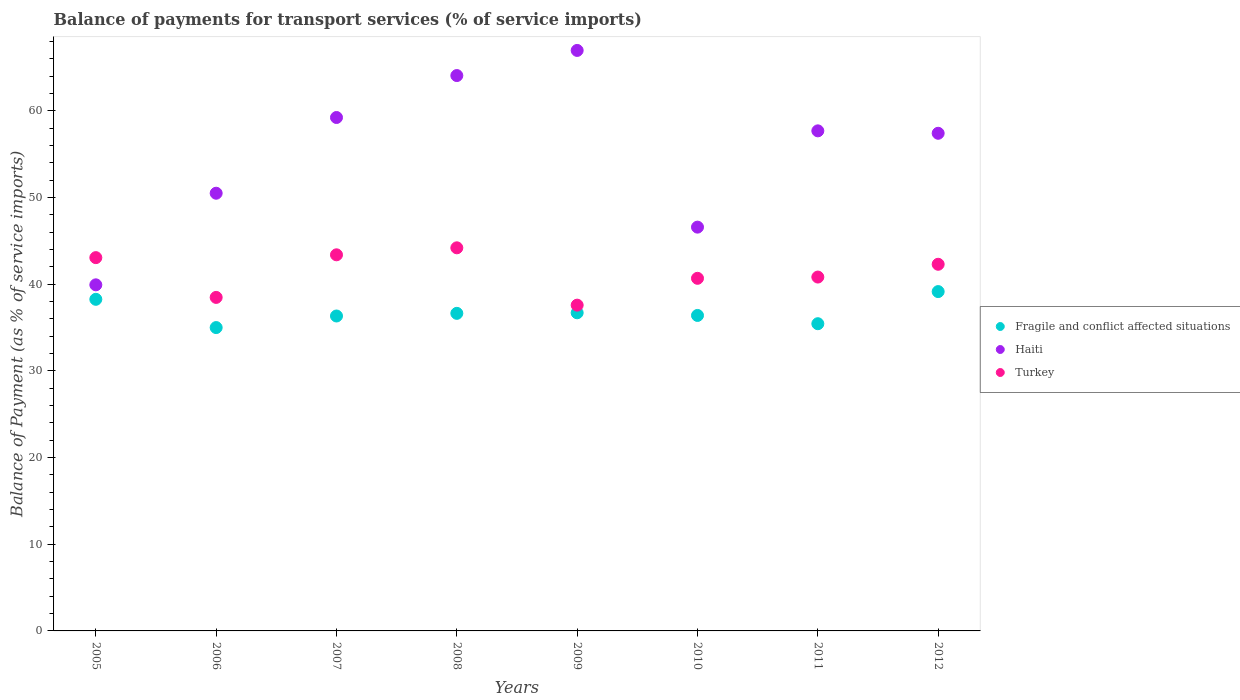How many different coloured dotlines are there?
Provide a short and direct response. 3. What is the balance of payments for transport services in Haiti in 2008?
Give a very brief answer. 64.07. Across all years, what is the maximum balance of payments for transport services in Fragile and conflict affected situations?
Your answer should be compact. 39.15. Across all years, what is the minimum balance of payments for transport services in Fragile and conflict affected situations?
Give a very brief answer. 34.99. In which year was the balance of payments for transport services in Fragile and conflict affected situations maximum?
Keep it short and to the point. 2012. In which year was the balance of payments for transport services in Fragile and conflict affected situations minimum?
Ensure brevity in your answer.  2006. What is the total balance of payments for transport services in Turkey in the graph?
Your response must be concise. 330.5. What is the difference between the balance of payments for transport services in Turkey in 2010 and that in 2012?
Keep it short and to the point. -1.62. What is the difference between the balance of payments for transport services in Fragile and conflict affected situations in 2006 and the balance of payments for transport services in Turkey in 2010?
Your answer should be compact. -5.68. What is the average balance of payments for transport services in Haiti per year?
Make the answer very short. 55.29. In the year 2011, what is the difference between the balance of payments for transport services in Turkey and balance of payments for transport services in Haiti?
Offer a very short reply. -16.87. In how many years, is the balance of payments for transport services in Haiti greater than 32 %?
Offer a very short reply. 8. What is the ratio of the balance of payments for transport services in Fragile and conflict affected situations in 2006 to that in 2012?
Provide a short and direct response. 0.89. What is the difference between the highest and the second highest balance of payments for transport services in Fragile and conflict affected situations?
Offer a very short reply. 0.89. What is the difference between the highest and the lowest balance of payments for transport services in Turkey?
Make the answer very short. 6.61. Is the sum of the balance of payments for transport services in Haiti in 2006 and 2009 greater than the maximum balance of payments for transport services in Turkey across all years?
Your answer should be very brief. Yes. Is the balance of payments for transport services in Haiti strictly greater than the balance of payments for transport services in Fragile and conflict affected situations over the years?
Your answer should be very brief. Yes. Is the balance of payments for transport services in Haiti strictly less than the balance of payments for transport services in Turkey over the years?
Ensure brevity in your answer.  No. Are the values on the major ticks of Y-axis written in scientific E-notation?
Keep it short and to the point. No. Does the graph contain any zero values?
Your response must be concise. No. Where does the legend appear in the graph?
Give a very brief answer. Center right. How many legend labels are there?
Provide a succinct answer. 3. How are the legend labels stacked?
Your answer should be compact. Vertical. What is the title of the graph?
Offer a terse response. Balance of payments for transport services (% of service imports). Does "Guatemala" appear as one of the legend labels in the graph?
Offer a terse response. No. What is the label or title of the Y-axis?
Keep it short and to the point. Balance of Payment (as % of service imports). What is the Balance of Payment (as % of service imports) in Fragile and conflict affected situations in 2005?
Offer a terse response. 38.25. What is the Balance of Payment (as % of service imports) in Haiti in 2005?
Your response must be concise. 39.93. What is the Balance of Payment (as % of service imports) in Turkey in 2005?
Offer a very short reply. 43.06. What is the Balance of Payment (as % of service imports) in Fragile and conflict affected situations in 2006?
Provide a short and direct response. 34.99. What is the Balance of Payment (as % of service imports) in Haiti in 2006?
Your answer should be compact. 50.49. What is the Balance of Payment (as % of service imports) in Turkey in 2006?
Your answer should be compact. 38.47. What is the Balance of Payment (as % of service imports) in Fragile and conflict affected situations in 2007?
Your answer should be very brief. 36.33. What is the Balance of Payment (as % of service imports) in Haiti in 2007?
Give a very brief answer. 59.23. What is the Balance of Payment (as % of service imports) of Turkey in 2007?
Your answer should be very brief. 43.39. What is the Balance of Payment (as % of service imports) of Fragile and conflict affected situations in 2008?
Provide a succinct answer. 36.64. What is the Balance of Payment (as % of service imports) in Haiti in 2008?
Give a very brief answer. 64.07. What is the Balance of Payment (as % of service imports) of Turkey in 2008?
Your answer should be compact. 44.2. What is the Balance of Payment (as % of service imports) of Fragile and conflict affected situations in 2009?
Provide a short and direct response. 36.7. What is the Balance of Payment (as % of service imports) in Haiti in 2009?
Keep it short and to the point. 66.97. What is the Balance of Payment (as % of service imports) in Turkey in 2009?
Ensure brevity in your answer.  37.58. What is the Balance of Payment (as % of service imports) of Fragile and conflict affected situations in 2010?
Provide a succinct answer. 36.39. What is the Balance of Payment (as % of service imports) in Haiti in 2010?
Provide a short and direct response. 46.58. What is the Balance of Payment (as % of service imports) in Turkey in 2010?
Offer a very short reply. 40.68. What is the Balance of Payment (as % of service imports) of Fragile and conflict affected situations in 2011?
Ensure brevity in your answer.  35.44. What is the Balance of Payment (as % of service imports) of Haiti in 2011?
Make the answer very short. 57.69. What is the Balance of Payment (as % of service imports) in Turkey in 2011?
Keep it short and to the point. 40.82. What is the Balance of Payment (as % of service imports) in Fragile and conflict affected situations in 2012?
Offer a terse response. 39.15. What is the Balance of Payment (as % of service imports) in Haiti in 2012?
Give a very brief answer. 57.41. What is the Balance of Payment (as % of service imports) of Turkey in 2012?
Offer a terse response. 42.3. Across all years, what is the maximum Balance of Payment (as % of service imports) of Fragile and conflict affected situations?
Your answer should be very brief. 39.15. Across all years, what is the maximum Balance of Payment (as % of service imports) of Haiti?
Provide a succinct answer. 66.97. Across all years, what is the maximum Balance of Payment (as % of service imports) of Turkey?
Provide a succinct answer. 44.2. Across all years, what is the minimum Balance of Payment (as % of service imports) in Fragile and conflict affected situations?
Your response must be concise. 34.99. Across all years, what is the minimum Balance of Payment (as % of service imports) of Haiti?
Offer a very short reply. 39.93. Across all years, what is the minimum Balance of Payment (as % of service imports) in Turkey?
Make the answer very short. 37.58. What is the total Balance of Payment (as % of service imports) in Fragile and conflict affected situations in the graph?
Provide a short and direct response. 293.89. What is the total Balance of Payment (as % of service imports) of Haiti in the graph?
Your response must be concise. 442.35. What is the total Balance of Payment (as % of service imports) in Turkey in the graph?
Make the answer very short. 330.5. What is the difference between the Balance of Payment (as % of service imports) in Fragile and conflict affected situations in 2005 and that in 2006?
Your answer should be compact. 3.26. What is the difference between the Balance of Payment (as % of service imports) in Haiti in 2005 and that in 2006?
Provide a succinct answer. -10.57. What is the difference between the Balance of Payment (as % of service imports) in Turkey in 2005 and that in 2006?
Keep it short and to the point. 4.59. What is the difference between the Balance of Payment (as % of service imports) of Fragile and conflict affected situations in 2005 and that in 2007?
Offer a very short reply. 1.92. What is the difference between the Balance of Payment (as % of service imports) of Haiti in 2005 and that in 2007?
Provide a succinct answer. -19.3. What is the difference between the Balance of Payment (as % of service imports) in Turkey in 2005 and that in 2007?
Your answer should be compact. -0.33. What is the difference between the Balance of Payment (as % of service imports) in Fragile and conflict affected situations in 2005 and that in 2008?
Keep it short and to the point. 1.62. What is the difference between the Balance of Payment (as % of service imports) of Haiti in 2005 and that in 2008?
Make the answer very short. -24.14. What is the difference between the Balance of Payment (as % of service imports) of Turkey in 2005 and that in 2008?
Keep it short and to the point. -1.13. What is the difference between the Balance of Payment (as % of service imports) of Fragile and conflict affected situations in 2005 and that in 2009?
Your answer should be compact. 1.55. What is the difference between the Balance of Payment (as % of service imports) in Haiti in 2005 and that in 2009?
Your answer should be very brief. -27.04. What is the difference between the Balance of Payment (as % of service imports) of Turkey in 2005 and that in 2009?
Ensure brevity in your answer.  5.48. What is the difference between the Balance of Payment (as % of service imports) of Fragile and conflict affected situations in 2005 and that in 2010?
Offer a very short reply. 1.86. What is the difference between the Balance of Payment (as % of service imports) of Haiti in 2005 and that in 2010?
Your response must be concise. -6.66. What is the difference between the Balance of Payment (as % of service imports) in Turkey in 2005 and that in 2010?
Offer a very short reply. 2.39. What is the difference between the Balance of Payment (as % of service imports) of Fragile and conflict affected situations in 2005 and that in 2011?
Ensure brevity in your answer.  2.81. What is the difference between the Balance of Payment (as % of service imports) of Haiti in 2005 and that in 2011?
Your response must be concise. -17.76. What is the difference between the Balance of Payment (as % of service imports) in Turkey in 2005 and that in 2011?
Make the answer very short. 2.24. What is the difference between the Balance of Payment (as % of service imports) in Fragile and conflict affected situations in 2005 and that in 2012?
Offer a very short reply. -0.89. What is the difference between the Balance of Payment (as % of service imports) of Haiti in 2005 and that in 2012?
Give a very brief answer. -17.48. What is the difference between the Balance of Payment (as % of service imports) in Turkey in 2005 and that in 2012?
Your answer should be very brief. 0.77. What is the difference between the Balance of Payment (as % of service imports) of Fragile and conflict affected situations in 2006 and that in 2007?
Offer a terse response. -1.33. What is the difference between the Balance of Payment (as % of service imports) in Haiti in 2006 and that in 2007?
Your answer should be very brief. -8.74. What is the difference between the Balance of Payment (as % of service imports) of Turkey in 2006 and that in 2007?
Keep it short and to the point. -4.91. What is the difference between the Balance of Payment (as % of service imports) of Fragile and conflict affected situations in 2006 and that in 2008?
Keep it short and to the point. -1.64. What is the difference between the Balance of Payment (as % of service imports) in Haiti in 2006 and that in 2008?
Your answer should be compact. -13.57. What is the difference between the Balance of Payment (as % of service imports) of Turkey in 2006 and that in 2008?
Ensure brevity in your answer.  -5.72. What is the difference between the Balance of Payment (as % of service imports) in Fragile and conflict affected situations in 2006 and that in 2009?
Give a very brief answer. -1.71. What is the difference between the Balance of Payment (as % of service imports) in Haiti in 2006 and that in 2009?
Ensure brevity in your answer.  -16.47. What is the difference between the Balance of Payment (as % of service imports) of Turkey in 2006 and that in 2009?
Make the answer very short. 0.89. What is the difference between the Balance of Payment (as % of service imports) in Fragile and conflict affected situations in 2006 and that in 2010?
Give a very brief answer. -1.4. What is the difference between the Balance of Payment (as % of service imports) in Haiti in 2006 and that in 2010?
Ensure brevity in your answer.  3.91. What is the difference between the Balance of Payment (as % of service imports) in Turkey in 2006 and that in 2010?
Keep it short and to the point. -2.2. What is the difference between the Balance of Payment (as % of service imports) of Fragile and conflict affected situations in 2006 and that in 2011?
Your response must be concise. -0.45. What is the difference between the Balance of Payment (as % of service imports) in Haiti in 2006 and that in 2011?
Offer a very short reply. -7.2. What is the difference between the Balance of Payment (as % of service imports) in Turkey in 2006 and that in 2011?
Your answer should be very brief. -2.35. What is the difference between the Balance of Payment (as % of service imports) of Fragile and conflict affected situations in 2006 and that in 2012?
Make the answer very short. -4.15. What is the difference between the Balance of Payment (as % of service imports) in Haiti in 2006 and that in 2012?
Your response must be concise. -6.92. What is the difference between the Balance of Payment (as % of service imports) in Turkey in 2006 and that in 2012?
Your answer should be very brief. -3.82. What is the difference between the Balance of Payment (as % of service imports) in Fragile and conflict affected situations in 2007 and that in 2008?
Offer a very short reply. -0.31. What is the difference between the Balance of Payment (as % of service imports) of Haiti in 2007 and that in 2008?
Give a very brief answer. -4.84. What is the difference between the Balance of Payment (as % of service imports) in Turkey in 2007 and that in 2008?
Ensure brevity in your answer.  -0.81. What is the difference between the Balance of Payment (as % of service imports) in Fragile and conflict affected situations in 2007 and that in 2009?
Give a very brief answer. -0.37. What is the difference between the Balance of Payment (as % of service imports) of Haiti in 2007 and that in 2009?
Provide a succinct answer. -7.74. What is the difference between the Balance of Payment (as % of service imports) of Turkey in 2007 and that in 2009?
Your answer should be very brief. 5.81. What is the difference between the Balance of Payment (as % of service imports) of Fragile and conflict affected situations in 2007 and that in 2010?
Your answer should be very brief. -0.06. What is the difference between the Balance of Payment (as % of service imports) in Haiti in 2007 and that in 2010?
Your response must be concise. 12.65. What is the difference between the Balance of Payment (as % of service imports) of Turkey in 2007 and that in 2010?
Ensure brevity in your answer.  2.71. What is the difference between the Balance of Payment (as % of service imports) of Fragile and conflict affected situations in 2007 and that in 2011?
Offer a very short reply. 0.89. What is the difference between the Balance of Payment (as % of service imports) of Haiti in 2007 and that in 2011?
Provide a short and direct response. 1.54. What is the difference between the Balance of Payment (as % of service imports) in Turkey in 2007 and that in 2011?
Ensure brevity in your answer.  2.57. What is the difference between the Balance of Payment (as % of service imports) in Fragile and conflict affected situations in 2007 and that in 2012?
Keep it short and to the point. -2.82. What is the difference between the Balance of Payment (as % of service imports) in Haiti in 2007 and that in 2012?
Keep it short and to the point. 1.82. What is the difference between the Balance of Payment (as % of service imports) of Turkey in 2007 and that in 2012?
Make the answer very short. 1.09. What is the difference between the Balance of Payment (as % of service imports) in Fragile and conflict affected situations in 2008 and that in 2009?
Provide a succinct answer. -0.07. What is the difference between the Balance of Payment (as % of service imports) of Haiti in 2008 and that in 2009?
Your response must be concise. -2.9. What is the difference between the Balance of Payment (as % of service imports) in Turkey in 2008 and that in 2009?
Keep it short and to the point. 6.61. What is the difference between the Balance of Payment (as % of service imports) of Fragile and conflict affected situations in 2008 and that in 2010?
Ensure brevity in your answer.  0.24. What is the difference between the Balance of Payment (as % of service imports) in Haiti in 2008 and that in 2010?
Your answer should be compact. 17.49. What is the difference between the Balance of Payment (as % of service imports) of Turkey in 2008 and that in 2010?
Ensure brevity in your answer.  3.52. What is the difference between the Balance of Payment (as % of service imports) in Fragile and conflict affected situations in 2008 and that in 2011?
Your response must be concise. 1.2. What is the difference between the Balance of Payment (as % of service imports) of Haiti in 2008 and that in 2011?
Give a very brief answer. 6.38. What is the difference between the Balance of Payment (as % of service imports) of Turkey in 2008 and that in 2011?
Keep it short and to the point. 3.37. What is the difference between the Balance of Payment (as % of service imports) in Fragile and conflict affected situations in 2008 and that in 2012?
Offer a very short reply. -2.51. What is the difference between the Balance of Payment (as % of service imports) in Haiti in 2008 and that in 2012?
Keep it short and to the point. 6.66. What is the difference between the Balance of Payment (as % of service imports) of Turkey in 2008 and that in 2012?
Your answer should be very brief. 1.9. What is the difference between the Balance of Payment (as % of service imports) of Fragile and conflict affected situations in 2009 and that in 2010?
Your answer should be compact. 0.31. What is the difference between the Balance of Payment (as % of service imports) in Haiti in 2009 and that in 2010?
Offer a very short reply. 20.38. What is the difference between the Balance of Payment (as % of service imports) in Turkey in 2009 and that in 2010?
Provide a short and direct response. -3.1. What is the difference between the Balance of Payment (as % of service imports) of Fragile and conflict affected situations in 2009 and that in 2011?
Ensure brevity in your answer.  1.26. What is the difference between the Balance of Payment (as % of service imports) in Haiti in 2009 and that in 2011?
Your answer should be very brief. 9.28. What is the difference between the Balance of Payment (as % of service imports) of Turkey in 2009 and that in 2011?
Offer a terse response. -3.24. What is the difference between the Balance of Payment (as % of service imports) in Fragile and conflict affected situations in 2009 and that in 2012?
Provide a short and direct response. -2.45. What is the difference between the Balance of Payment (as % of service imports) in Haiti in 2009 and that in 2012?
Your response must be concise. 9.56. What is the difference between the Balance of Payment (as % of service imports) of Turkey in 2009 and that in 2012?
Offer a terse response. -4.71. What is the difference between the Balance of Payment (as % of service imports) of Fragile and conflict affected situations in 2010 and that in 2011?
Make the answer very short. 0.95. What is the difference between the Balance of Payment (as % of service imports) in Haiti in 2010 and that in 2011?
Keep it short and to the point. -11.11. What is the difference between the Balance of Payment (as % of service imports) of Turkey in 2010 and that in 2011?
Offer a terse response. -0.15. What is the difference between the Balance of Payment (as % of service imports) of Fragile and conflict affected situations in 2010 and that in 2012?
Keep it short and to the point. -2.75. What is the difference between the Balance of Payment (as % of service imports) of Haiti in 2010 and that in 2012?
Your response must be concise. -10.83. What is the difference between the Balance of Payment (as % of service imports) of Turkey in 2010 and that in 2012?
Give a very brief answer. -1.62. What is the difference between the Balance of Payment (as % of service imports) in Fragile and conflict affected situations in 2011 and that in 2012?
Your response must be concise. -3.71. What is the difference between the Balance of Payment (as % of service imports) of Haiti in 2011 and that in 2012?
Give a very brief answer. 0.28. What is the difference between the Balance of Payment (as % of service imports) in Turkey in 2011 and that in 2012?
Your answer should be compact. -1.47. What is the difference between the Balance of Payment (as % of service imports) of Fragile and conflict affected situations in 2005 and the Balance of Payment (as % of service imports) of Haiti in 2006?
Give a very brief answer. -12.24. What is the difference between the Balance of Payment (as % of service imports) in Fragile and conflict affected situations in 2005 and the Balance of Payment (as % of service imports) in Turkey in 2006?
Give a very brief answer. -0.22. What is the difference between the Balance of Payment (as % of service imports) in Haiti in 2005 and the Balance of Payment (as % of service imports) in Turkey in 2006?
Provide a succinct answer. 1.45. What is the difference between the Balance of Payment (as % of service imports) of Fragile and conflict affected situations in 2005 and the Balance of Payment (as % of service imports) of Haiti in 2007?
Your response must be concise. -20.97. What is the difference between the Balance of Payment (as % of service imports) in Fragile and conflict affected situations in 2005 and the Balance of Payment (as % of service imports) in Turkey in 2007?
Your answer should be compact. -5.13. What is the difference between the Balance of Payment (as % of service imports) in Haiti in 2005 and the Balance of Payment (as % of service imports) in Turkey in 2007?
Provide a succinct answer. -3.46. What is the difference between the Balance of Payment (as % of service imports) of Fragile and conflict affected situations in 2005 and the Balance of Payment (as % of service imports) of Haiti in 2008?
Give a very brief answer. -25.81. What is the difference between the Balance of Payment (as % of service imports) of Fragile and conflict affected situations in 2005 and the Balance of Payment (as % of service imports) of Turkey in 2008?
Your answer should be compact. -5.94. What is the difference between the Balance of Payment (as % of service imports) in Haiti in 2005 and the Balance of Payment (as % of service imports) in Turkey in 2008?
Offer a very short reply. -4.27. What is the difference between the Balance of Payment (as % of service imports) in Fragile and conflict affected situations in 2005 and the Balance of Payment (as % of service imports) in Haiti in 2009?
Make the answer very short. -28.71. What is the difference between the Balance of Payment (as % of service imports) of Fragile and conflict affected situations in 2005 and the Balance of Payment (as % of service imports) of Turkey in 2009?
Offer a terse response. 0.67. What is the difference between the Balance of Payment (as % of service imports) of Haiti in 2005 and the Balance of Payment (as % of service imports) of Turkey in 2009?
Your answer should be compact. 2.34. What is the difference between the Balance of Payment (as % of service imports) of Fragile and conflict affected situations in 2005 and the Balance of Payment (as % of service imports) of Haiti in 2010?
Make the answer very short. -8.33. What is the difference between the Balance of Payment (as % of service imports) in Fragile and conflict affected situations in 2005 and the Balance of Payment (as % of service imports) in Turkey in 2010?
Your answer should be very brief. -2.42. What is the difference between the Balance of Payment (as % of service imports) of Haiti in 2005 and the Balance of Payment (as % of service imports) of Turkey in 2010?
Ensure brevity in your answer.  -0.75. What is the difference between the Balance of Payment (as % of service imports) in Fragile and conflict affected situations in 2005 and the Balance of Payment (as % of service imports) in Haiti in 2011?
Provide a succinct answer. -19.43. What is the difference between the Balance of Payment (as % of service imports) of Fragile and conflict affected situations in 2005 and the Balance of Payment (as % of service imports) of Turkey in 2011?
Give a very brief answer. -2.57. What is the difference between the Balance of Payment (as % of service imports) of Haiti in 2005 and the Balance of Payment (as % of service imports) of Turkey in 2011?
Offer a terse response. -0.9. What is the difference between the Balance of Payment (as % of service imports) of Fragile and conflict affected situations in 2005 and the Balance of Payment (as % of service imports) of Haiti in 2012?
Make the answer very short. -19.15. What is the difference between the Balance of Payment (as % of service imports) of Fragile and conflict affected situations in 2005 and the Balance of Payment (as % of service imports) of Turkey in 2012?
Keep it short and to the point. -4.04. What is the difference between the Balance of Payment (as % of service imports) in Haiti in 2005 and the Balance of Payment (as % of service imports) in Turkey in 2012?
Ensure brevity in your answer.  -2.37. What is the difference between the Balance of Payment (as % of service imports) of Fragile and conflict affected situations in 2006 and the Balance of Payment (as % of service imports) of Haiti in 2007?
Offer a very short reply. -24.23. What is the difference between the Balance of Payment (as % of service imports) in Fragile and conflict affected situations in 2006 and the Balance of Payment (as % of service imports) in Turkey in 2007?
Provide a succinct answer. -8.39. What is the difference between the Balance of Payment (as % of service imports) of Haiti in 2006 and the Balance of Payment (as % of service imports) of Turkey in 2007?
Your answer should be very brief. 7.1. What is the difference between the Balance of Payment (as % of service imports) of Fragile and conflict affected situations in 2006 and the Balance of Payment (as % of service imports) of Haiti in 2008?
Provide a short and direct response. -29.07. What is the difference between the Balance of Payment (as % of service imports) of Fragile and conflict affected situations in 2006 and the Balance of Payment (as % of service imports) of Turkey in 2008?
Make the answer very short. -9.2. What is the difference between the Balance of Payment (as % of service imports) in Haiti in 2006 and the Balance of Payment (as % of service imports) in Turkey in 2008?
Your response must be concise. 6.3. What is the difference between the Balance of Payment (as % of service imports) in Fragile and conflict affected situations in 2006 and the Balance of Payment (as % of service imports) in Haiti in 2009?
Your answer should be very brief. -31.97. What is the difference between the Balance of Payment (as % of service imports) in Fragile and conflict affected situations in 2006 and the Balance of Payment (as % of service imports) in Turkey in 2009?
Provide a succinct answer. -2.59. What is the difference between the Balance of Payment (as % of service imports) of Haiti in 2006 and the Balance of Payment (as % of service imports) of Turkey in 2009?
Provide a succinct answer. 12.91. What is the difference between the Balance of Payment (as % of service imports) of Fragile and conflict affected situations in 2006 and the Balance of Payment (as % of service imports) of Haiti in 2010?
Keep it short and to the point. -11.59. What is the difference between the Balance of Payment (as % of service imports) of Fragile and conflict affected situations in 2006 and the Balance of Payment (as % of service imports) of Turkey in 2010?
Your answer should be compact. -5.68. What is the difference between the Balance of Payment (as % of service imports) in Haiti in 2006 and the Balance of Payment (as % of service imports) in Turkey in 2010?
Make the answer very short. 9.82. What is the difference between the Balance of Payment (as % of service imports) of Fragile and conflict affected situations in 2006 and the Balance of Payment (as % of service imports) of Haiti in 2011?
Give a very brief answer. -22.69. What is the difference between the Balance of Payment (as % of service imports) in Fragile and conflict affected situations in 2006 and the Balance of Payment (as % of service imports) in Turkey in 2011?
Your response must be concise. -5.83. What is the difference between the Balance of Payment (as % of service imports) of Haiti in 2006 and the Balance of Payment (as % of service imports) of Turkey in 2011?
Keep it short and to the point. 9.67. What is the difference between the Balance of Payment (as % of service imports) in Fragile and conflict affected situations in 2006 and the Balance of Payment (as % of service imports) in Haiti in 2012?
Offer a terse response. -22.41. What is the difference between the Balance of Payment (as % of service imports) in Fragile and conflict affected situations in 2006 and the Balance of Payment (as % of service imports) in Turkey in 2012?
Your answer should be very brief. -7.3. What is the difference between the Balance of Payment (as % of service imports) of Haiti in 2006 and the Balance of Payment (as % of service imports) of Turkey in 2012?
Ensure brevity in your answer.  8.2. What is the difference between the Balance of Payment (as % of service imports) of Fragile and conflict affected situations in 2007 and the Balance of Payment (as % of service imports) of Haiti in 2008?
Provide a short and direct response. -27.74. What is the difference between the Balance of Payment (as % of service imports) of Fragile and conflict affected situations in 2007 and the Balance of Payment (as % of service imports) of Turkey in 2008?
Your answer should be very brief. -7.87. What is the difference between the Balance of Payment (as % of service imports) in Haiti in 2007 and the Balance of Payment (as % of service imports) in Turkey in 2008?
Provide a short and direct response. 15.03. What is the difference between the Balance of Payment (as % of service imports) of Fragile and conflict affected situations in 2007 and the Balance of Payment (as % of service imports) of Haiti in 2009?
Your answer should be very brief. -30.64. What is the difference between the Balance of Payment (as % of service imports) in Fragile and conflict affected situations in 2007 and the Balance of Payment (as % of service imports) in Turkey in 2009?
Offer a terse response. -1.25. What is the difference between the Balance of Payment (as % of service imports) of Haiti in 2007 and the Balance of Payment (as % of service imports) of Turkey in 2009?
Give a very brief answer. 21.65. What is the difference between the Balance of Payment (as % of service imports) of Fragile and conflict affected situations in 2007 and the Balance of Payment (as % of service imports) of Haiti in 2010?
Your response must be concise. -10.25. What is the difference between the Balance of Payment (as % of service imports) in Fragile and conflict affected situations in 2007 and the Balance of Payment (as % of service imports) in Turkey in 2010?
Your response must be concise. -4.35. What is the difference between the Balance of Payment (as % of service imports) in Haiti in 2007 and the Balance of Payment (as % of service imports) in Turkey in 2010?
Keep it short and to the point. 18.55. What is the difference between the Balance of Payment (as % of service imports) in Fragile and conflict affected situations in 2007 and the Balance of Payment (as % of service imports) in Haiti in 2011?
Ensure brevity in your answer.  -21.36. What is the difference between the Balance of Payment (as % of service imports) of Fragile and conflict affected situations in 2007 and the Balance of Payment (as % of service imports) of Turkey in 2011?
Provide a short and direct response. -4.49. What is the difference between the Balance of Payment (as % of service imports) in Haiti in 2007 and the Balance of Payment (as % of service imports) in Turkey in 2011?
Ensure brevity in your answer.  18.41. What is the difference between the Balance of Payment (as % of service imports) of Fragile and conflict affected situations in 2007 and the Balance of Payment (as % of service imports) of Haiti in 2012?
Make the answer very short. -21.08. What is the difference between the Balance of Payment (as % of service imports) in Fragile and conflict affected situations in 2007 and the Balance of Payment (as % of service imports) in Turkey in 2012?
Provide a short and direct response. -5.97. What is the difference between the Balance of Payment (as % of service imports) of Haiti in 2007 and the Balance of Payment (as % of service imports) of Turkey in 2012?
Offer a very short reply. 16.93. What is the difference between the Balance of Payment (as % of service imports) of Fragile and conflict affected situations in 2008 and the Balance of Payment (as % of service imports) of Haiti in 2009?
Provide a short and direct response. -30.33. What is the difference between the Balance of Payment (as % of service imports) of Fragile and conflict affected situations in 2008 and the Balance of Payment (as % of service imports) of Turkey in 2009?
Ensure brevity in your answer.  -0.95. What is the difference between the Balance of Payment (as % of service imports) in Haiti in 2008 and the Balance of Payment (as % of service imports) in Turkey in 2009?
Your answer should be compact. 26.48. What is the difference between the Balance of Payment (as % of service imports) of Fragile and conflict affected situations in 2008 and the Balance of Payment (as % of service imports) of Haiti in 2010?
Give a very brief answer. -9.95. What is the difference between the Balance of Payment (as % of service imports) in Fragile and conflict affected situations in 2008 and the Balance of Payment (as % of service imports) in Turkey in 2010?
Provide a short and direct response. -4.04. What is the difference between the Balance of Payment (as % of service imports) of Haiti in 2008 and the Balance of Payment (as % of service imports) of Turkey in 2010?
Ensure brevity in your answer.  23.39. What is the difference between the Balance of Payment (as % of service imports) of Fragile and conflict affected situations in 2008 and the Balance of Payment (as % of service imports) of Haiti in 2011?
Provide a short and direct response. -21.05. What is the difference between the Balance of Payment (as % of service imports) of Fragile and conflict affected situations in 2008 and the Balance of Payment (as % of service imports) of Turkey in 2011?
Ensure brevity in your answer.  -4.19. What is the difference between the Balance of Payment (as % of service imports) in Haiti in 2008 and the Balance of Payment (as % of service imports) in Turkey in 2011?
Make the answer very short. 23.24. What is the difference between the Balance of Payment (as % of service imports) of Fragile and conflict affected situations in 2008 and the Balance of Payment (as % of service imports) of Haiti in 2012?
Ensure brevity in your answer.  -20.77. What is the difference between the Balance of Payment (as % of service imports) of Fragile and conflict affected situations in 2008 and the Balance of Payment (as % of service imports) of Turkey in 2012?
Offer a very short reply. -5.66. What is the difference between the Balance of Payment (as % of service imports) of Haiti in 2008 and the Balance of Payment (as % of service imports) of Turkey in 2012?
Make the answer very short. 21.77. What is the difference between the Balance of Payment (as % of service imports) of Fragile and conflict affected situations in 2009 and the Balance of Payment (as % of service imports) of Haiti in 2010?
Your answer should be compact. -9.88. What is the difference between the Balance of Payment (as % of service imports) in Fragile and conflict affected situations in 2009 and the Balance of Payment (as % of service imports) in Turkey in 2010?
Your response must be concise. -3.98. What is the difference between the Balance of Payment (as % of service imports) of Haiti in 2009 and the Balance of Payment (as % of service imports) of Turkey in 2010?
Offer a very short reply. 26.29. What is the difference between the Balance of Payment (as % of service imports) of Fragile and conflict affected situations in 2009 and the Balance of Payment (as % of service imports) of Haiti in 2011?
Make the answer very short. -20.99. What is the difference between the Balance of Payment (as % of service imports) of Fragile and conflict affected situations in 2009 and the Balance of Payment (as % of service imports) of Turkey in 2011?
Provide a short and direct response. -4.12. What is the difference between the Balance of Payment (as % of service imports) in Haiti in 2009 and the Balance of Payment (as % of service imports) in Turkey in 2011?
Offer a terse response. 26.14. What is the difference between the Balance of Payment (as % of service imports) in Fragile and conflict affected situations in 2009 and the Balance of Payment (as % of service imports) in Haiti in 2012?
Your answer should be very brief. -20.71. What is the difference between the Balance of Payment (as % of service imports) of Fragile and conflict affected situations in 2009 and the Balance of Payment (as % of service imports) of Turkey in 2012?
Your response must be concise. -5.6. What is the difference between the Balance of Payment (as % of service imports) in Haiti in 2009 and the Balance of Payment (as % of service imports) in Turkey in 2012?
Provide a succinct answer. 24.67. What is the difference between the Balance of Payment (as % of service imports) of Fragile and conflict affected situations in 2010 and the Balance of Payment (as % of service imports) of Haiti in 2011?
Offer a terse response. -21.29. What is the difference between the Balance of Payment (as % of service imports) of Fragile and conflict affected situations in 2010 and the Balance of Payment (as % of service imports) of Turkey in 2011?
Provide a short and direct response. -4.43. What is the difference between the Balance of Payment (as % of service imports) of Haiti in 2010 and the Balance of Payment (as % of service imports) of Turkey in 2011?
Give a very brief answer. 5.76. What is the difference between the Balance of Payment (as % of service imports) of Fragile and conflict affected situations in 2010 and the Balance of Payment (as % of service imports) of Haiti in 2012?
Offer a terse response. -21.01. What is the difference between the Balance of Payment (as % of service imports) of Fragile and conflict affected situations in 2010 and the Balance of Payment (as % of service imports) of Turkey in 2012?
Your response must be concise. -5.9. What is the difference between the Balance of Payment (as % of service imports) of Haiti in 2010 and the Balance of Payment (as % of service imports) of Turkey in 2012?
Make the answer very short. 4.28. What is the difference between the Balance of Payment (as % of service imports) of Fragile and conflict affected situations in 2011 and the Balance of Payment (as % of service imports) of Haiti in 2012?
Your response must be concise. -21.97. What is the difference between the Balance of Payment (as % of service imports) in Fragile and conflict affected situations in 2011 and the Balance of Payment (as % of service imports) in Turkey in 2012?
Keep it short and to the point. -6.86. What is the difference between the Balance of Payment (as % of service imports) in Haiti in 2011 and the Balance of Payment (as % of service imports) in Turkey in 2012?
Your response must be concise. 15.39. What is the average Balance of Payment (as % of service imports) of Fragile and conflict affected situations per year?
Ensure brevity in your answer.  36.74. What is the average Balance of Payment (as % of service imports) in Haiti per year?
Provide a short and direct response. 55.29. What is the average Balance of Payment (as % of service imports) in Turkey per year?
Keep it short and to the point. 41.31. In the year 2005, what is the difference between the Balance of Payment (as % of service imports) in Fragile and conflict affected situations and Balance of Payment (as % of service imports) in Haiti?
Provide a succinct answer. -1.67. In the year 2005, what is the difference between the Balance of Payment (as % of service imports) of Fragile and conflict affected situations and Balance of Payment (as % of service imports) of Turkey?
Offer a terse response. -4.81. In the year 2005, what is the difference between the Balance of Payment (as % of service imports) of Haiti and Balance of Payment (as % of service imports) of Turkey?
Make the answer very short. -3.14. In the year 2006, what is the difference between the Balance of Payment (as % of service imports) of Fragile and conflict affected situations and Balance of Payment (as % of service imports) of Haiti?
Make the answer very short. -15.5. In the year 2006, what is the difference between the Balance of Payment (as % of service imports) of Fragile and conflict affected situations and Balance of Payment (as % of service imports) of Turkey?
Give a very brief answer. -3.48. In the year 2006, what is the difference between the Balance of Payment (as % of service imports) in Haiti and Balance of Payment (as % of service imports) in Turkey?
Offer a very short reply. 12.02. In the year 2007, what is the difference between the Balance of Payment (as % of service imports) in Fragile and conflict affected situations and Balance of Payment (as % of service imports) in Haiti?
Offer a very short reply. -22.9. In the year 2007, what is the difference between the Balance of Payment (as % of service imports) in Fragile and conflict affected situations and Balance of Payment (as % of service imports) in Turkey?
Your response must be concise. -7.06. In the year 2007, what is the difference between the Balance of Payment (as % of service imports) in Haiti and Balance of Payment (as % of service imports) in Turkey?
Your answer should be very brief. 15.84. In the year 2008, what is the difference between the Balance of Payment (as % of service imports) in Fragile and conflict affected situations and Balance of Payment (as % of service imports) in Haiti?
Provide a succinct answer. -27.43. In the year 2008, what is the difference between the Balance of Payment (as % of service imports) of Fragile and conflict affected situations and Balance of Payment (as % of service imports) of Turkey?
Your response must be concise. -7.56. In the year 2008, what is the difference between the Balance of Payment (as % of service imports) of Haiti and Balance of Payment (as % of service imports) of Turkey?
Your answer should be compact. 19.87. In the year 2009, what is the difference between the Balance of Payment (as % of service imports) in Fragile and conflict affected situations and Balance of Payment (as % of service imports) in Haiti?
Offer a very short reply. -30.26. In the year 2009, what is the difference between the Balance of Payment (as % of service imports) of Fragile and conflict affected situations and Balance of Payment (as % of service imports) of Turkey?
Offer a very short reply. -0.88. In the year 2009, what is the difference between the Balance of Payment (as % of service imports) in Haiti and Balance of Payment (as % of service imports) in Turkey?
Offer a very short reply. 29.38. In the year 2010, what is the difference between the Balance of Payment (as % of service imports) of Fragile and conflict affected situations and Balance of Payment (as % of service imports) of Haiti?
Keep it short and to the point. -10.19. In the year 2010, what is the difference between the Balance of Payment (as % of service imports) in Fragile and conflict affected situations and Balance of Payment (as % of service imports) in Turkey?
Your answer should be compact. -4.28. In the year 2010, what is the difference between the Balance of Payment (as % of service imports) of Haiti and Balance of Payment (as % of service imports) of Turkey?
Make the answer very short. 5.9. In the year 2011, what is the difference between the Balance of Payment (as % of service imports) in Fragile and conflict affected situations and Balance of Payment (as % of service imports) in Haiti?
Your response must be concise. -22.25. In the year 2011, what is the difference between the Balance of Payment (as % of service imports) in Fragile and conflict affected situations and Balance of Payment (as % of service imports) in Turkey?
Provide a short and direct response. -5.38. In the year 2011, what is the difference between the Balance of Payment (as % of service imports) in Haiti and Balance of Payment (as % of service imports) in Turkey?
Offer a very short reply. 16.87. In the year 2012, what is the difference between the Balance of Payment (as % of service imports) of Fragile and conflict affected situations and Balance of Payment (as % of service imports) of Haiti?
Provide a succinct answer. -18.26. In the year 2012, what is the difference between the Balance of Payment (as % of service imports) of Fragile and conflict affected situations and Balance of Payment (as % of service imports) of Turkey?
Offer a very short reply. -3.15. In the year 2012, what is the difference between the Balance of Payment (as % of service imports) in Haiti and Balance of Payment (as % of service imports) in Turkey?
Offer a terse response. 15.11. What is the ratio of the Balance of Payment (as % of service imports) of Fragile and conflict affected situations in 2005 to that in 2006?
Provide a short and direct response. 1.09. What is the ratio of the Balance of Payment (as % of service imports) of Haiti in 2005 to that in 2006?
Provide a succinct answer. 0.79. What is the ratio of the Balance of Payment (as % of service imports) in Turkey in 2005 to that in 2006?
Offer a terse response. 1.12. What is the ratio of the Balance of Payment (as % of service imports) of Fragile and conflict affected situations in 2005 to that in 2007?
Keep it short and to the point. 1.05. What is the ratio of the Balance of Payment (as % of service imports) of Haiti in 2005 to that in 2007?
Your answer should be very brief. 0.67. What is the ratio of the Balance of Payment (as % of service imports) in Fragile and conflict affected situations in 2005 to that in 2008?
Give a very brief answer. 1.04. What is the ratio of the Balance of Payment (as % of service imports) in Haiti in 2005 to that in 2008?
Make the answer very short. 0.62. What is the ratio of the Balance of Payment (as % of service imports) in Turkey in 2005 to that in 2008?
Ensure brevity in your answer.  0.97. What is the ratio of the Balance of Payment (as % of service imports) of Fragile and conflict affected situations in 2005 to that in 2009?
Provide a short and direct response. 1.04. What is the ratio of the Balance of Payment (as % of service imports) of Haiti in 2005 to that in 2009?
Your answer should be very brief. 0.6. What is the ratio of the Balance of Payment (as % of service imports) of Turkey in 2005 to that in 2009?
Offer a very short reply. 1.15. What is the ratio of the Balance of Payment (as % of service imports) in Fragile and conflict affected situations in 2005 to that in 2010?
Ensure brevity in your answer.  1.05. What is the ratio of the Balance of Payment (as % of service imports) of Turkey in 2005 to that in 2010?
Your answer should be compact. 1.06. What is the ratio of the Balance of Payment (as % of service imports) in Fragile and conflict affected situations in 2005 to that in 2011?
Provide a succinct answer. 1.08. What is the ratio of the Balance of Payment (as % of service imports) of Haiti in 2005 to that in 2011?
Keep it short and to the point. 0.69. What is the ratio of the Balance of Payment (as % of service imports) in Turkey in 2005 to that in 2011?
Your answer should be very brief. 1.05. What is the ratio of the Balance of Payment (as % of service imports) of Fragile and conflict affected situations in 2005 to that in 2012?
Ensure brevity in your answer.  0.98. What is the ratio of the Balance of Payment (as % of service imports) in Haiti in 2005 to that in 2012?
Keep it short and to the point. 0.7. What is the ratio of the Balance of Payment (as % of service imports) in Turkey in 2005 to that in 2012?
Your answer should be very brief. 1.02. What is the ratio of the Balance of Payment (as % of service imports) in Fragile and conflict affected situations in 2006 to that in 2007?
Your answer should be compact. 0.96. What is the ratio of the Balance of Payment (as % of service imports) in Haiti in 2006 to that in 2007?
Your response must be concise. 0.85. What is the ratio of the Balance of Payment (as % of service imports) of Turkey in 2006 to that in 2007?
Offer a terse response. 0.89. What is the ratio of the Balance of Payment (as % of service imports) of Fragile and conflict affected situations in 2006 to that in 2008?
Give a very brief answer. 0.96. What is the ratio of the Balance of Payment (as % of service imports) in Haiti in 2006 to that in 2008?
Your answer should be compact. 0.79. What is the ratio of the Balance of Payment (as % of service imports) of Turkey in 2006 to that in 2008?
Offer a very short reply. 0.87. What is the ratio of the Balance of Payment (as % of service imports) in Fragile and conflict affected situations in 2006 to that in 2009?
Give a very brief answer. 0.95. What is the ratio of the Balance of Payment (as % of service imports) of Haiti in 2006 to that in 2009?
Your response must be concise. 0.75. What is the ratio of the Balance of Payment (as % of service imports) in Turkey in 2006 to that in 2009?
Your answer should be very brief. 1.02. What is the ratio of the Balance of Payment (as % of service imports) of Fragile and conflict affected situations in 2006 to that in 2010?
Keep it short and to the point. 0.96. What is the ratio of the Balance of Payment (as % of service imports) in Haiti in 2006 to that in 2010?
Your answer should be compact. 1.08. What is the ratio of the Balance of Payment (as % of service imports) of Turkey in 2006 to that in 2010?
Your response must be concise. 0.95. What is the ratio of the Balance of Payment (as % of service imports) in Fragile and conflict affected situations in 2006 to that in 2011?
Give a very brief answer. 0.99. What is the ratio of the Balance of Payment (as % of service imports) in Haiti in 2006 to that in 2011?
Provide a succinct answer. 0.88. What is the ratio of the Balance of Payment (as % of service imports) of Turkey in 2006 to that in 2011?
Provide a short and direct response. 0.94. What is the ratio of the Balance of Payment (as % of service imports) in Fragile and conflict affected situations in 2006 to that in 2012?
Provide a succinct answer. 0.89. What is the ratio of the Balance of Payment (as % of service imports) in Haiti in 2006 to that in 2012?
Offer a very short reply. 0.88. What is the ratio of the Balance of Payment (as % of service imports) in Turkey in 2006 to that in 2012?
Provide a short and direct response. 0.91. What is the ratio of the Balance of Payment (as % of service imports) in Haiti in 2007 to that in 2008?
Provide a succinct answer. 0.92. What is the ratio of the Balance of Payment (as % of service imports) of Turkey in 2007 to that in 2008?
Your response must be concise. 0.98. What is the ratio of the Balance of Payment (as % of service imports) of Fragile and conflict affected situations in 2007 to that in 2009?
Provide a short and direct response. 0.99. What is the ratio of the Balance of Payment (as % of service imports) of Haiti in 2007 to that in 2009?
Make the answer very short. 0.88. What is the ratio of the Balance of Payment (as % of service imports) in Turkey in 2007 to that in 2009?
Give a very brief answer. 1.15. What is the ratio of the Balance of Payment (as % of service imports) of Haiti in 2007 to that in 2010?
Your response must be concise. 1.27. What is the ratio of the Balance of Payment (as % of service imports) in Turkey in 2007 to that in 2010?
Provide a short and direct response. 1.07. What is the ratio of the Balance of Payment (as % of service imports) of Fragile and conflict affected situations in 2007 to that in 2011?
Ensure brevity in your answer.  1.03. What is the ratio of the Balance of Payment (as % of service imports) in Haiti in 2007 to that in 2011?
Your answer should be compact. 1.03. What is the ratio of the Balance of Payment (as % of service imports) in Turkey in 2007 to that in 2011?
Make the answer very short. 1.06. What is the ratio of the Balance of Payment (as % of service imports) in Fragile and conflict affected situations in 2007 to that in 2012?
Your answer should be very brief. 0.93. What is the ratio of the Balance of Payment (as % of service imports) of Haiti in 2007 to that in 2012?
Make the answer very short. 1.03. What is the ratio of the Balance of Payment (as % of service imports) of Turkey in 2007 to that in 2012?
Ensure brevity in your answer.  1.03. What is the ratio of the Balance of Payment (as % of service imports) of Fragile and conflict affected situations in 2008 to that in 2009?
Make the answer very short. 1. What is the ratio of the Balance of Payment (as % of service imports) in Haiti in 2008 to that in 2009?
Offer a terse response. 0.96. What is the ratio of the Balance of Payment (as % of service imports) of Turkey in 2008 to that in 2009?
Keep it short and to the point. 1.18. What is the ratio of the Balance of Payment (as % of service imports) of Fragile and conflict affected situations in 2008 to that in 2010?
Keep it short and to the point. 1.01. What is the ratio of the Balance of Payment (as % of service imports) of Haiti in 2008 to that in 2010?
Provide a short and direct response. 1.38. What is the ratio of the Balance of Payment (as % of service imports) of Turkey in 2008 to that in 2010?
Your answer should be compact. 1.09. What is the ratio of the Balance of Payment (as % of service imports) of Fragile and conflict affected situations in 2008 to that in 2011?
Provide a short and direct response. 1.03. What is the ratio of the Balance of Payment (as % of service imports) of Haiti in 2008 to that in 2011?
Offer a terse response. 1.11. What is the ratio of the Balance of Payment (as % of service imports) in Turkey in 2008 to that in 2011?
Ensure brevity in your answer.  1.08. What is the ratio of the Balance of Payment (as % of service imports) in Fragile and conflict affected situations in 2008 to that in 2012?
Keep it short and to the point. 0.94. What is the ratio of the Balance of Payment (as % of service imports) in Haiti in 2008 to that in 2012?
Provide a succinct answer. 1.12. What is the ratio of the Balance of Payment (as % of service imports) of Turkey in 2008 to that in 2012?
Your response must be concise. 1.04. What is the ratio of the Balance of Payment (as % of service imports) in Fragile and conflict affected situations in 2009 to that in 2010?
Your answer should be very brief. 1.01. What is the ratio of the Balance of Payment (as % of service imports) in Haiti in 2009 to that in 2010?
Keep it short and to the point. 1.44. What is the ratio of the Balance of Payment (as % of service imports) of Turkey in 2009 to that in 2010?
Provide a short and direct response. 0.92. What is the ratio of the Balance of Payment (as % of service imports) in Fragile and conflict affected situations in 2009 to that in 2011?
Offer a terse response. 1.04. What is the ratio of the Balance of Payment (as % of service imports) of Haiti in 2009 to that in 2011?
Make the answer very short. 1.16. What is the ratio of the Balance of Payment (as % of service imports) of Turkey in 2009 to that in 2011?
Your response must be concise. 0.92. What is the ratio of the Balance of Payment (as % of service imports) of Haiti in 2009 to that in 2012?
Keep it short and to the point. 1.17. What is the ratio of the Balance of Payment (as % of service imports) in Turkey in 2009 to that in 2012?
Keep it short and to the point. 0.89. What is the ratio of the Balance of Payment (as % of service imports) of Fragile and conflict affected situations in 2010 to that in 2011?
Offer a terse response. 1.03. What is the ratio of the Balance of Payment (as % of service imports) in Haiti in 2010 to that in 2011?
Your answer should be compact. 0.81. What is the ratio of the Balance of Payment (as % of service imports) in Fragile and conflict affected situations in 2010 to that in 2012?
Your response must be concise. 0.93. What is the ratio of the Balance of Payment (as % of service imports) in Haiti in 2010 to that in 2012?
Offer a very short reply. 0.81. What is the ratio of the Balance of Payment (as % of service imports) of Turkey in 2010 to that in 2012?
Your answer should be compact. 0.96. What is the ratio of the Balance of Payment (as % of service imports) in Fragile and conflict affected situations in 2011 to that in 2012?
Offer a terse response. 0.91. What is the ratio of the Balance of Payment (as % of service imports) of Turkey in 2011 to that in 2012?
Provide a succinct answer. 0.97. What is the difference between the highest and the second highest Balance of Payment (as % of service imports) of Fragile and conflict affected situations?
Make the answer very short. 0.89. What is the difference between the highest and the second highest Balance of Payment (as % of service imports) of Haiti?
Ensure brevity in your answer.  2.9. What is the difference between the highest and the second highest Balance of Payment (as % of service imports) in Turkey?
Give a very brief answer. 0.81. What is the difference between the highest and the lowest Balance of Payment (as % of service imports) in Fragile and conflict affected situations?
Keep it short and to the point. 4.15. What is the difference between the highest and the lowest Balance of Payment (as % of service imports) of Haiti?
Your answer should be very brief. 27.04. What is the difference between the highest and the lowest Balance of Payment (as % of service imports) in Turkey?
Provide a short and direct response. 6.61. 